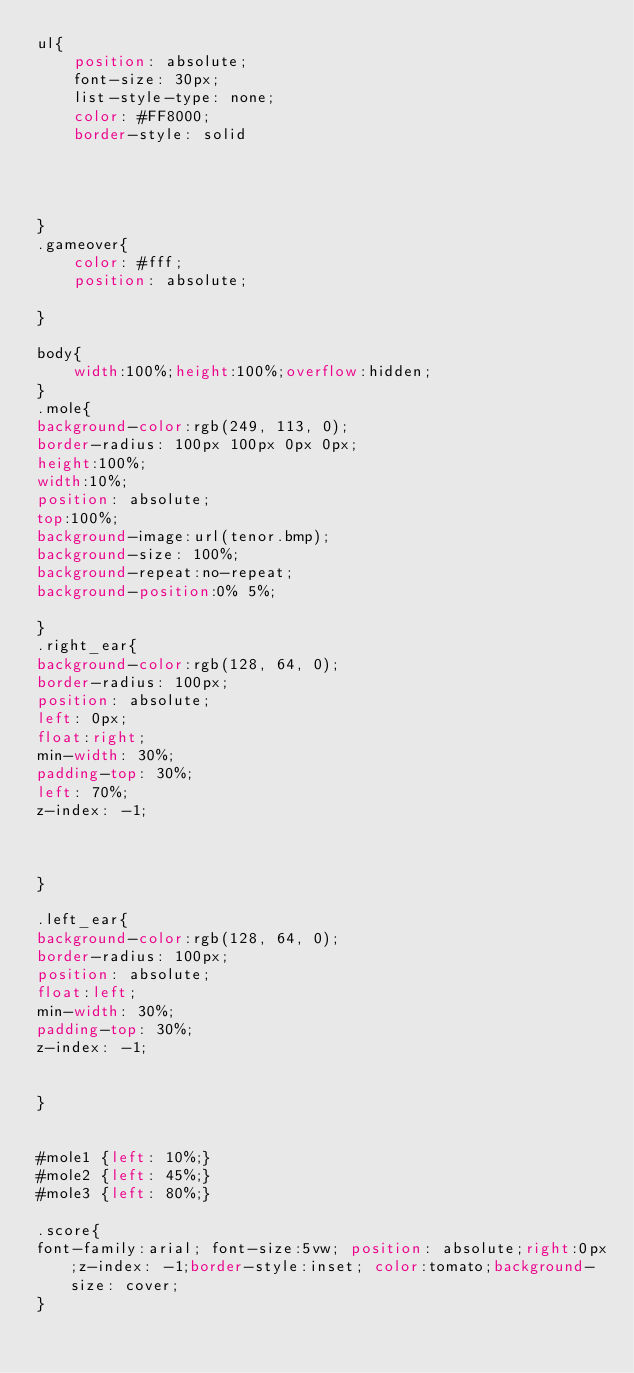<code> <loc_0><loc_0><loc_500><loc_500><_CSS_>ul{
    position: absolute;
    font-size: 30px;
    list-style-type: none;
    color: #FF8000;
    border-style: solid
    



}
.gameover{
    color: #fff;
    position: absolute;

}

body{
    width:100%;height:100%;overflow:hidden;
}
.mole{
background-color:rgb(249, 113, 0);
border-radius: 100px 100px 0px 0px;
height:100%;
width:10%;
position: absolute;
top:100%;
background-image:url(tenor.bmp);
background-size: 100%;
background-repeat:no-repeat;
background-position:0% 5%;

}
.right_ear{
background-color:rgb(128, 64, 0);
border-radius: 100px;
position: absolute;
left: 0px;
float:right;
min-width: 30%;
padding-top: 30%;
left: 70%;
z-index: -1;



}

.left_ear{
background-color:rgb(128, 64, 0);
border-radius: 100px;
position: absolute;
float:left;
min-width: 30%;
padding-top: 30%;
z-index: -1;


}


#mole1 {left: 10%;}
#mole2 {left: 45%;}
#mole3 {left: 80%;}

.score{
font-family:arial; font-size:5vw; position: absolute;right:0px;z-index: -1;border-style:inset; color:tomato;background-size: cover;
}


</code> 